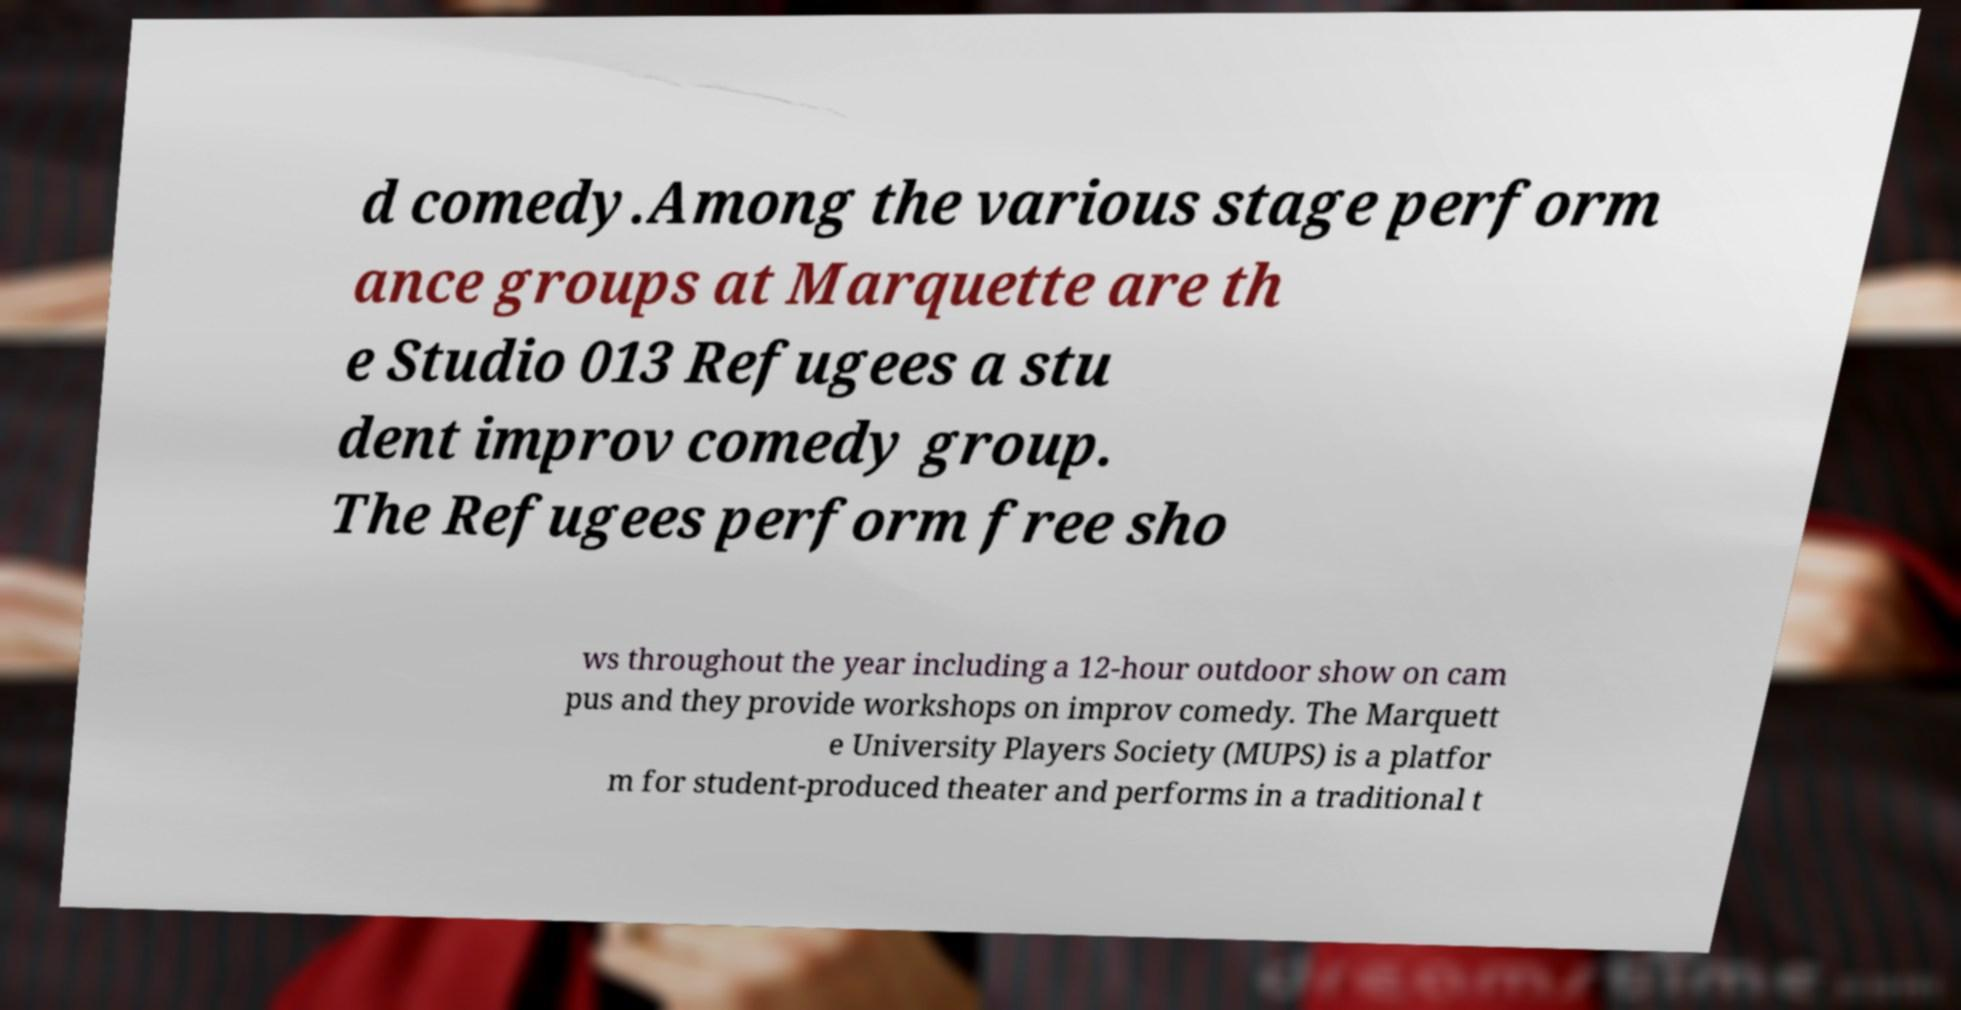Can you accurately transcribe the text from the provided image for me? d comedy.Among the various stage perform ance groups at Marquette are th e Studio 013 Refugees a stu dent improv comedy group. The Refugees perform free sho ws throughout the year including a 12-hour outdoor show on cam pus and they provide workshops on improv comedy. The Marquett e University Players Society (MUPS) is a platfor m for student-produced theater and performs in a traditional t 